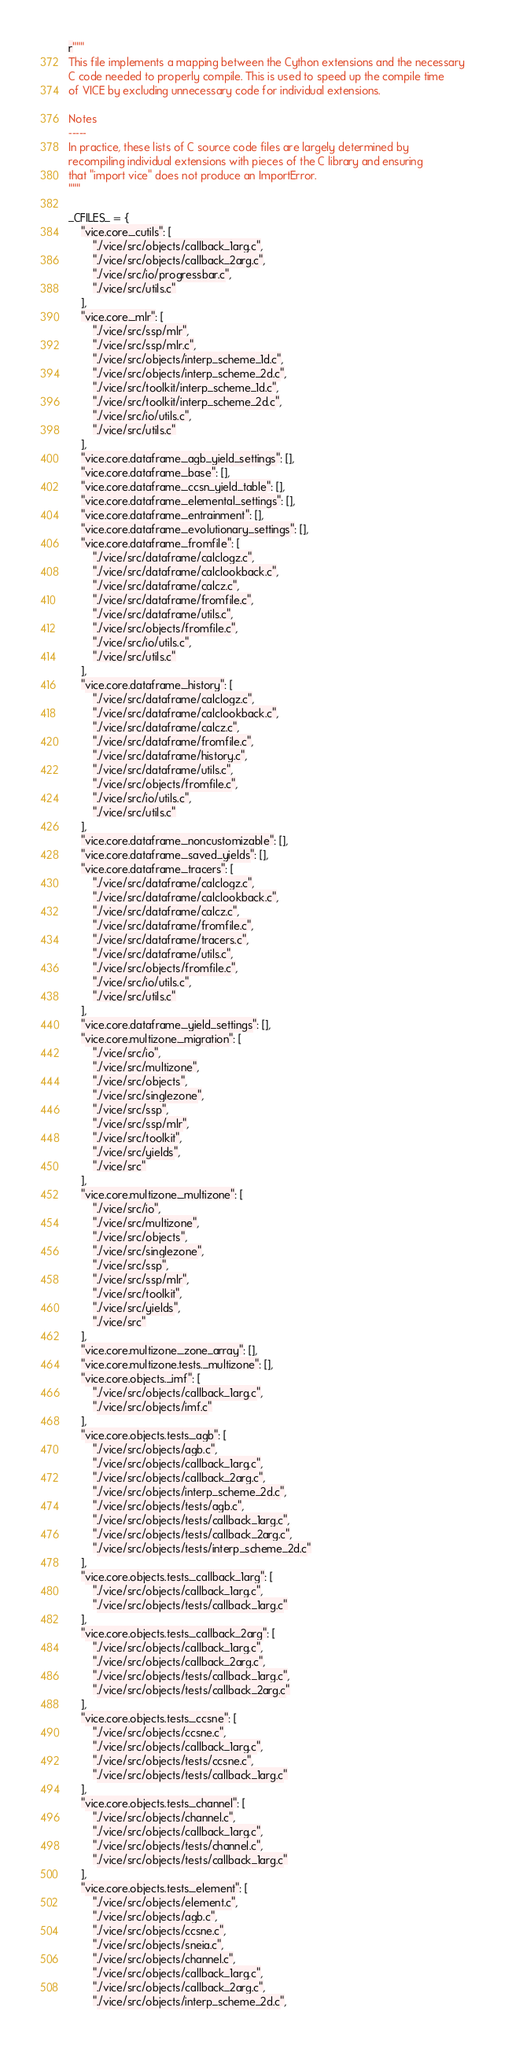Convert code to text. <code><loc_0><loc_0><loc_500><loc_500><_Python_>r"""
This file implements a mapping between the Cython extensions and the necessary
C code needed to properly compile. This is used to speed up the compile time
of VICE by excluding unnecessary code for individual extensions.

Notes
-----
In practice, these lists of C source code files are largely determined by
recompiling individual extensions with pieces of the C library and ensuring
that "import vice" does not produce an ImportError.
"""

_CFILES_ = {
	"vice.core._cutils": [
		"./vice/src/objects/callback_1arg.c",
		"./vice/src/objects/callback_2arg.c",
		"./vice/src/io/progressbar.c",
		"./vice/src/utils.c"
	],
	"vice.core._mlr": [
		"./vice/src/ssp/mlr",
		"./vice/src/ssp/mlr.c",
		"./vice/src/objects/interp_scheme_1d.c",
		"./vice/src/objects/interp_scheme_2d.c",
		"./vice/src/toolkit/interp_scheme_1d.c",
		"./vice/src/toolkit/interp_scheme_2d.c",
		"./vice/src/io/utils.c",
		"./vice/src/utils.c"
	],
	"vice.core.dataframe._agb_yield_settings": [],
	"vice.core.dataframe._base": [],
	"vice.core.dataframe._ccsn_yield_table": [],
	"vice.core.dataframe._elemental_settings": [],
	"vice.core.dataframe._entrainment": [],
	"vice.core.dataframe._evolutionary_settings": [],
	"vice.core.dataframe._fromfile": [
		"./vice/src/dataframe/calclogz.c",
		"./vice/src/dataframe/calclookback.c",
		"./vice/src/dataframe/calcz.c",
		"./vice/src/dataframe/fromfile.c",
		"./vice/src/dataframe/utils.c",
		"./vice/src/objects/fromfile.c",
		"./vice/src/io/utils.c",
		"./vice/src/utils.c"
	],
	"vice.core.dataframe._history": [
		"./vice/src/dataframe/calclogz.c",
		"./vice/src/dataframe/calclookback.c",
		"./vice/src/dataframe/calcz.c",
		"./vice/src/dataframe/fromfile.c",
		"./vice/src/dataframe/history.c",
		"./vice/src/dataframe/utils.c",
		"./vice/src/objects/fromfile.c",
		"./vice/src/io/utils.c",
		"./vice/src/utils.c"
	],
	"vice.core.dataframe._noncustomizable": [],
	"vice.core.dataframe._saved_yields": [],
	"vice.core.dataframe._tracers": [
		"./vice/src/dataframe/calclogz.c",
		"./vice/src/dataframe/calclookback.c",
		"./vice/src/dataframe/calcz.c",
		"./vice/src/dataframe/fromfile.c",
		"./vice/src/dataframe/tracers.c",
		"./vice/src/dataframe/utils.c",
		"./vice/src/objects/fromfile.c",
		"./vice/src/io/utils.c",
		"./vice/src/utils.c"
	],
	"vice.core.dataframe._yield_settings": [],
	"vice.core.multizone._migration": [
		"./vice/src/io",
		"./vice/src/multizone",
		"./vice/src/objects",
		"./vice/src/singlezone",
		"./vice/src/ssp",
		"./vice/src/ssp/mlr",
		"./vice/src/toolkit",
		"./vice/src/yields",
		"./vice/src"
	],
	"vice.core.multizone._multizone": [
		"./vice/src/io",
		"./vice/src/multizone",
		"./vice/src/objects",
		"./vice/src/singlezone",
		"./vice/src/ssp",
		"./vice/src/ssp/mlr",
		"./vice/src/toolkit",
		"./vice/src/yields",
		"./vice/src"
	],
	"vice.core.multizone._zone_array": [],
	"vice.core.multizone.tests._multizone": [],
	"vice.core.objects._imf": [
		"./vice/src/objects/callback_1arg.c",
		"./vice/src/objects/imf.c"
	],
	"vice.core.objects.tests._agb": [
		"./vice/src/objects/agb.c",
		"./vice/src/objects/callback_1arg.c",
		"./vice/src/objects/callback_2arg.c",
		"./vice/src/objects/interp_scheme_2d.c",
		"./vice/src/objects/tests/agb.c",
		"./vice/src/objects/tests/callback_1arg.c",
		"./vice/src/objects/tests/callback_2arg.c",
		"./vice/src/objects/tests/interp_scheme_2d.c"
	],
	"vice.core.objects.tests._callback_1arg": [
		"./vice/src/objects/callback_1arg.c",
		"./vice/src/objects/tests/callback_1arg.c"
	],
	"vice.core.objects.tests._callback_2arg": [
		"./vice/src/objects/callback_1arg.c",
		"./vice/src/objects/callback_2arg.c",
		"./vice/src/objects/tests/callback_1arg.c",
		"./vice/src/objects/tests/callback_2arg.c"
	],
	"vice.core.objects.tests._ccsne": [
		"./vice/src/objects/ccsne.c",
		"./vice/src/objects/callback_1arg.c",
		"./vice/src/objects/tests/ccsne.c",
		"./vice/src/objects/tests/callback_1arg.c"
	],
	"vice.core.objects.tests._channel": [
		"./vice/src/objects/channel.c",
		"./vice/src/objects/callback_1arg.c",
		"./vice/src/objects/tests/channel.c",
		"./vice/src/objects/tests/callback_1arg.c"
	],
	"vice.core.objects.tests._element": [
		"./vice/src/objects/element.c",
		"./vice/src/objects/agb.c",
		"./vice/src/objects/ccsne.c",
		"./vice/src/objects/sneia.c",
		"./vice/src/objects/channel.c",
		"./vice/src/objects/callback_1arg.c",
		"./vice/src/objects/callback_2arg.c",
		"./vice/src/objects/interp_scheme_2d.c",</code> 